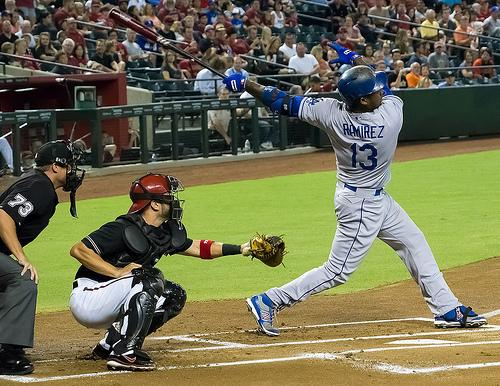In the context of a product advertisement task, identify a sportswear brand visible on an object in the image. The brand Nike is visible on the catchers red and black baseball cleats. In the picture, can you identify an equipment in the hands of the catcher behind the hitter? Yes, the catcher is holding a brown and black catchers mitt in his hands. What valuable information is printed on the back of the batter's shirt in the picture? The batter's shirt displays the player's last name and the number 13. For the visual entailment task, what major action is being portrayed by the baseball player in the image? The major action portrayed is a baseball player swinging at the ball with a bat. What is the umpire in the image wearing on his head? The umpire is wearing a black hat on his head. What are the colors of the batting gloves worn by the batter in the image? The batter is wearing blue batting gloves. For the multi-choice VQA task, what are the primary colors of the cleats worn by the catcher?  The primary colors of the catchers cleats are red and black. Based on the image, describe the protective gear that the catcher is wearing. The catcher is wearing a red helmet, black shin guards, and catchers red and black Nike baseball cleats. 